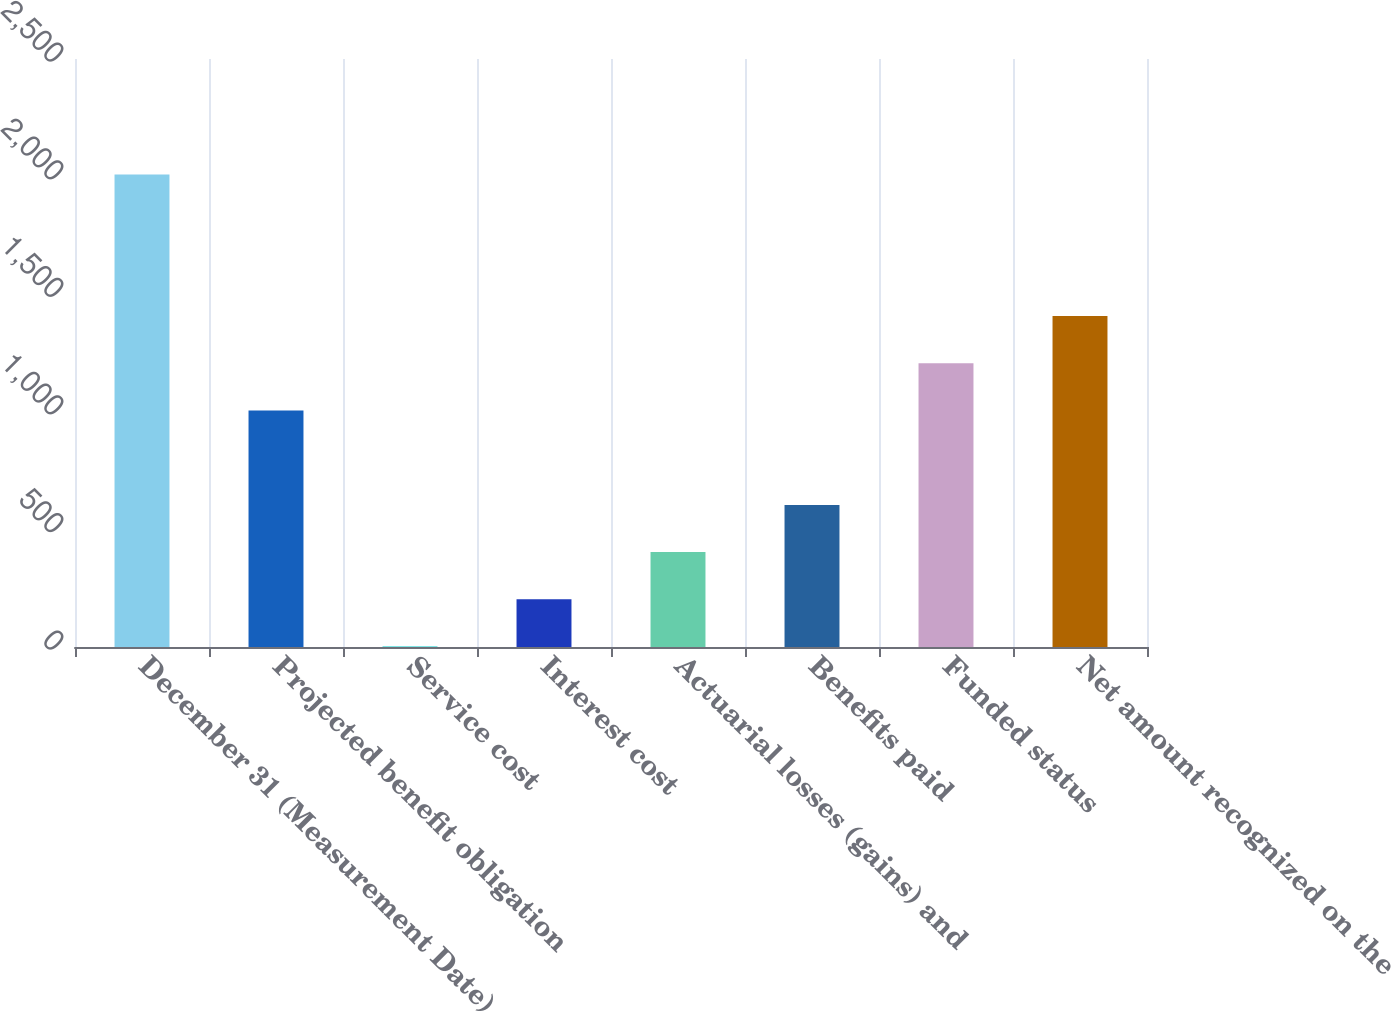Convert chart. <chart><loc_0><loc_0><loc_500><loc_500><bar_chart><fcel>December 31 (Measurement Date)<fcel>Projected benefit obligation<fcel>Service cost<fcel>Interest cost<fcel>Actuarial losses (gains) and<fcel>Benefits paid<fcel>Funded status<fcel>Net amount recognized on the<nl><fcel>2009<fcel>1005.5<fcel>2<fcel>202.7<fcel>403.4<fcel>604.1<fcel>1206.2<fcel>1406.9<nl></chart> 